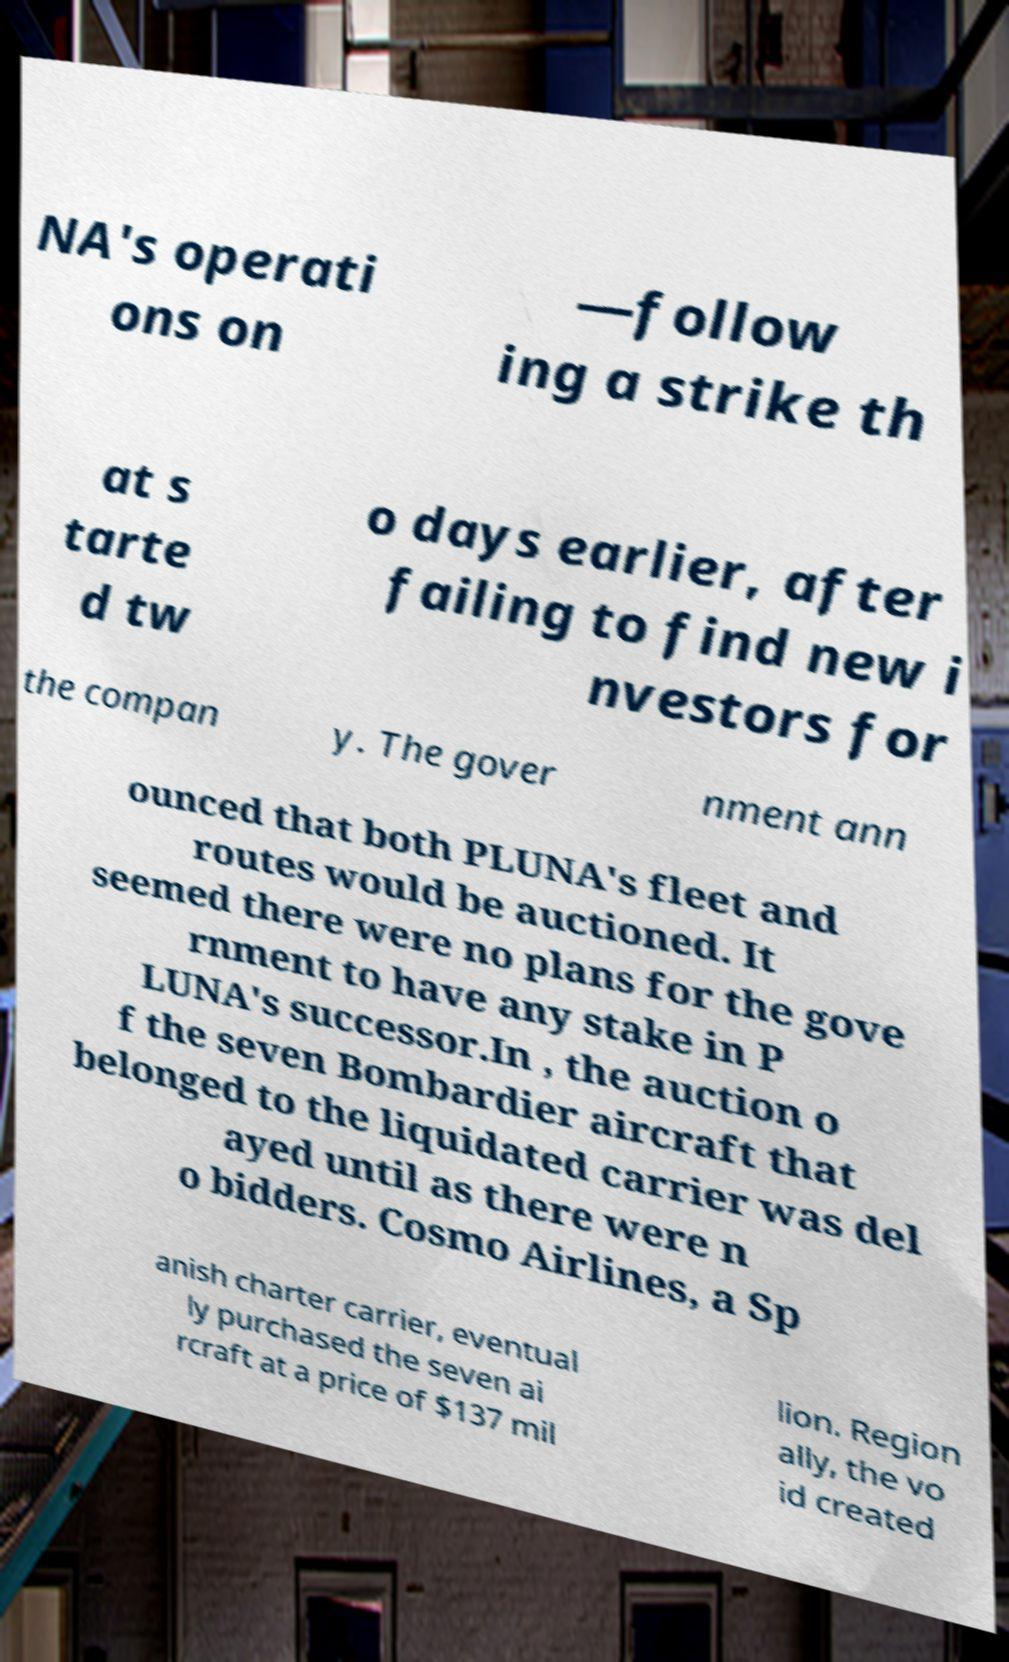I need the written content from this picture converted into text. Can you do that? NA's operati ons on —follow ing a strike th at s tarte d tw o days earlier, after failing to find new i nvestors for the compan y. The gover nment ann ounced that both PLUNA's fleet and routes would be auctioned. It seemed there were no plans for the gove rnment to have any stake in P LUNA's successor.In , the auction o f the seven Bombardier aircraft that belonged to the liquidated carrier was del ayed until as there were n o bidders. Cosmo Airlines, a Sp anish charter carrier, eventual ly purchased the seven ai rcraft at a price of $137 mil lion. Region ally, the vo id created 